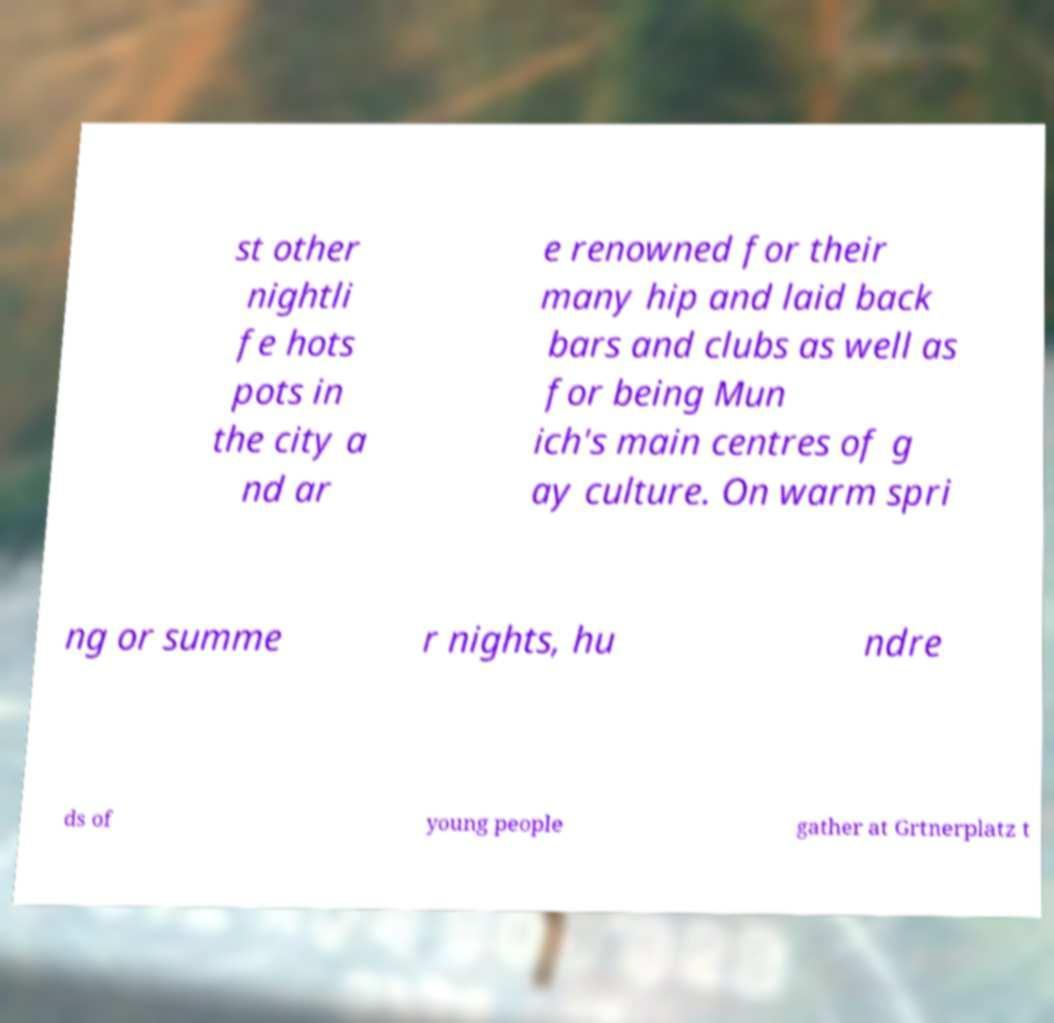Could you extract and type out the text from this image? st other nightli fe hots pots in the city a nd ar e renowned for their many hip and laid back bars and clubs as well as for being Mun ich's main centres of g ay culture. On warm spri ng or summe r nights, hu ndre ds of young people gather at Grtnerplatz t 